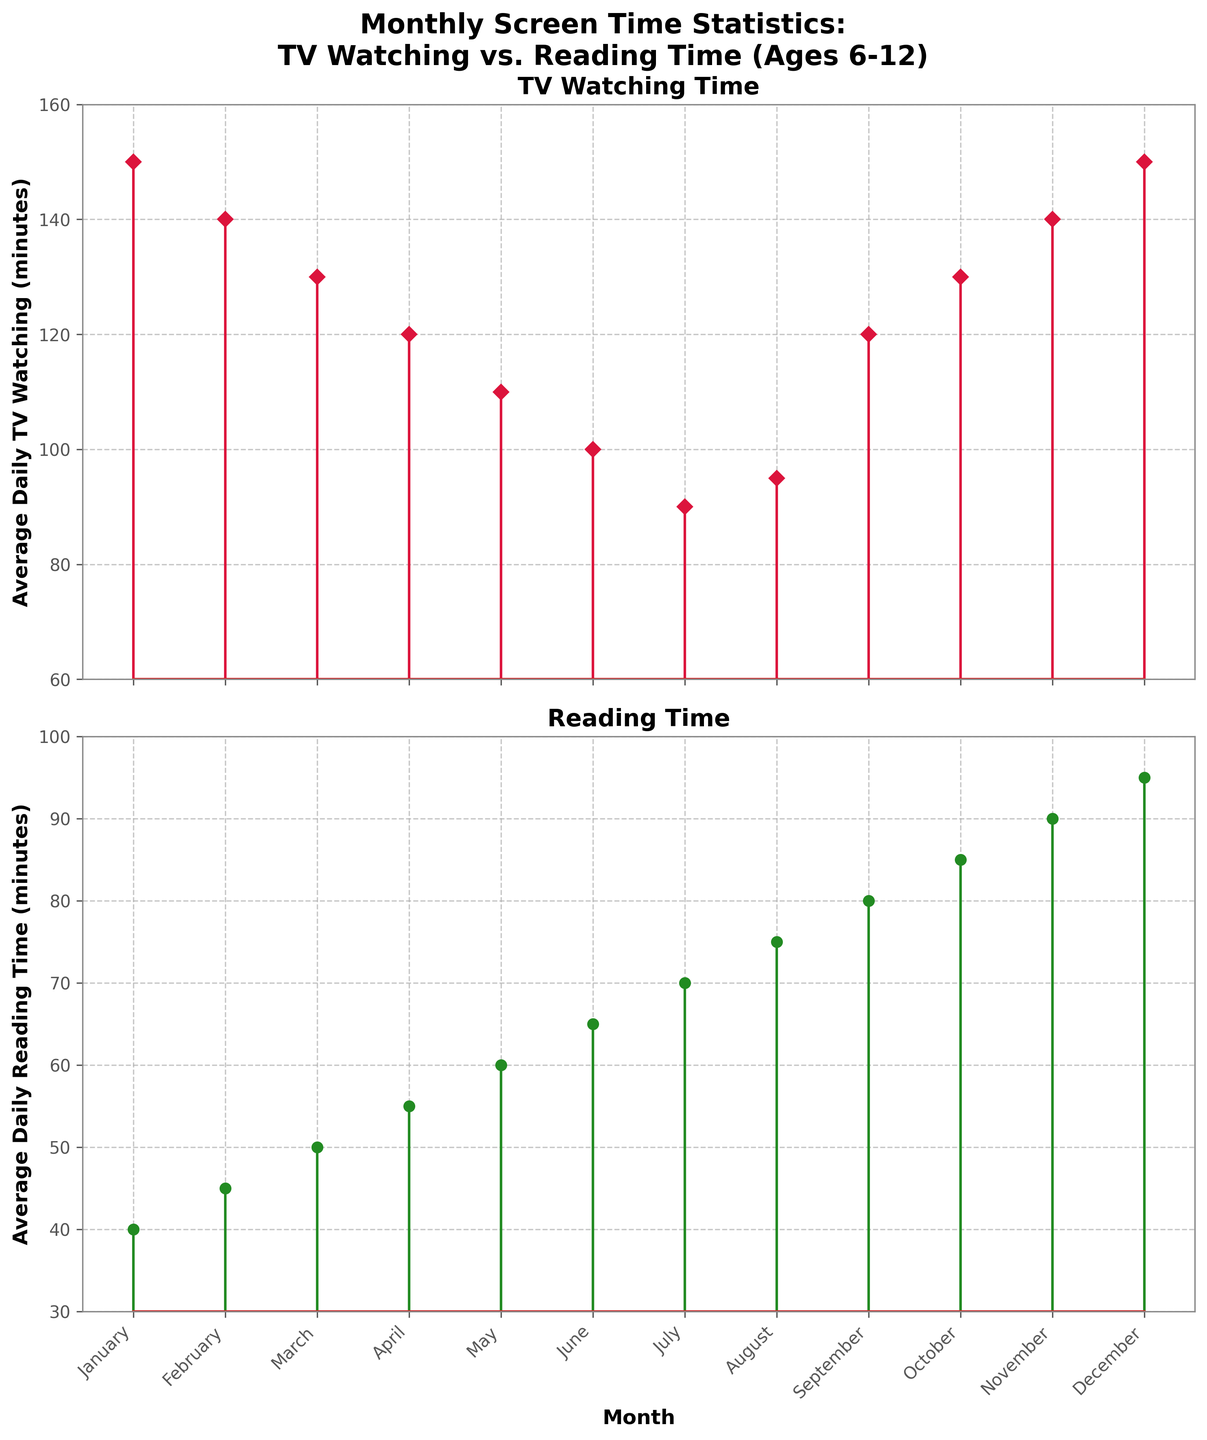What is the average daily TV watching time in January? The average daily TV watching time for January is indicated by the top of the stem plot on the "TV Watching Time" subplot. In January, this is 150 minutes.
Answer: 150 minutes How does the TV watching time change from August to September? The "TV Watching Time" subplot shows that in August, the average time is 95 minutes and in September, it is 120 minutes. The change is the difference between these values: 120 minutes - 95 minutes = 25 minutes.
Answer: Increased by 25 minutes Which month has the highest average daily reading time? The highest point on the reading time stem plot indicates the month with the highest average daily reading time. This point, at 95 minutes, is in December.
Answer: December Which month shows the smallest difference between TV watching time and reading time? To find the smallest difference, you need to calculate the difference for each month and compare them. August has the smallest difference of 20 minutes (95 minutes watching - 75 minutes reading).
Answer: August In which months do children read for more than 70 minutes daily on average? The "Reading Time" subplot shows months above the 70-minute line: July, August, September, October, November, and December.
Answer: July through December What is the percentage decrease in average daily TV watching time from January to July? The decrease in TV watching from January (150 minutes) to July (90 minutes) is 60 minutes. The percentage decrease is (60/150) * 100 = 40%.
Answer: 40% What is the trend in average daily reading time from January to December? The "Reading Time" subplot shows a mostly increasing trend from January (40 minutes) to December (95 minutes).
Answer: Increasing trend How does the average daily reading time in July compare to that in January and November? In July, the average reading time is 70 minutes. In January, it is 40 minutes, and in November, it is 90 minutes. July reading time is greater than January's but less than November's.
Answer: Greater than January; less than November Is there any month where the average daily TV watching time and reading time are equal? Looking at the subplots, no month shows equal values for TV watching and reading time.
Answer: No How much more time do children spend on average watching TV than reading in October? In October, the average daily TV watching time is 130 minutes and reading time is 85 minutes. The difference is 130 - 85 = 45 minutes.
Answer: 45 minutes 